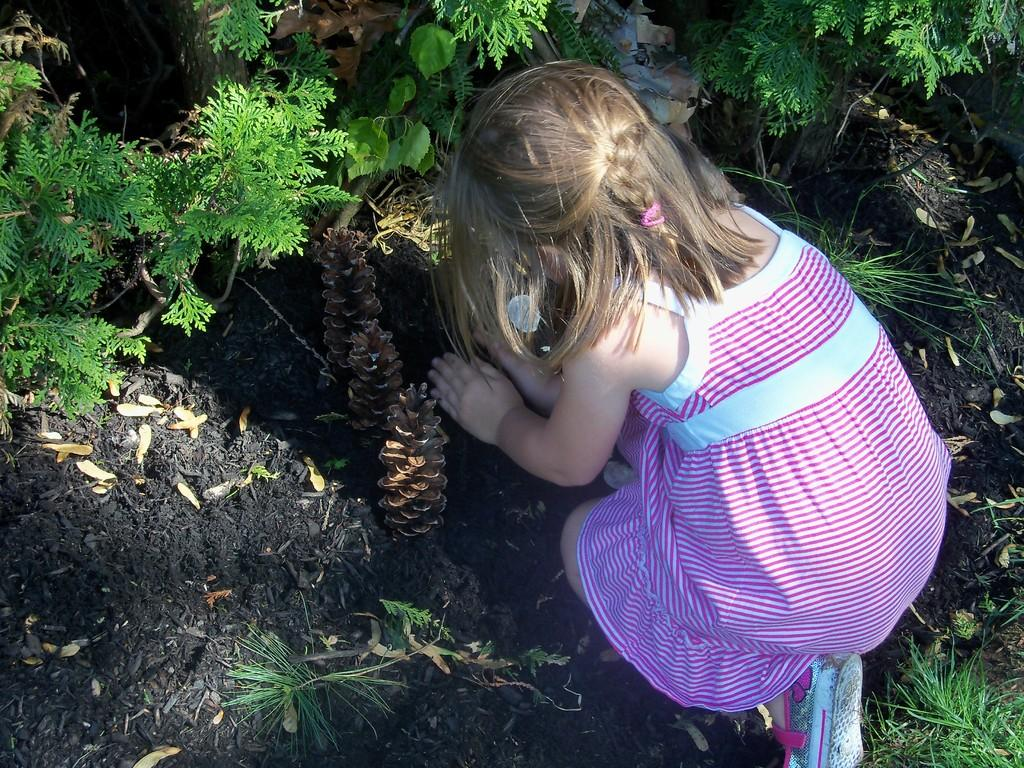What is the main subject of the image? The main subject of the image is a kid. What is the kid holding in the image? The kid is holding a plant in the image. What type of terrain can be seen in the image? There is sand visible in the image. What else is present in the image besides the kid and the sand? There are plants in the image. What type of paste is being used by the kid in the image? There is no paste present in the image; the kid is holding a plant. 